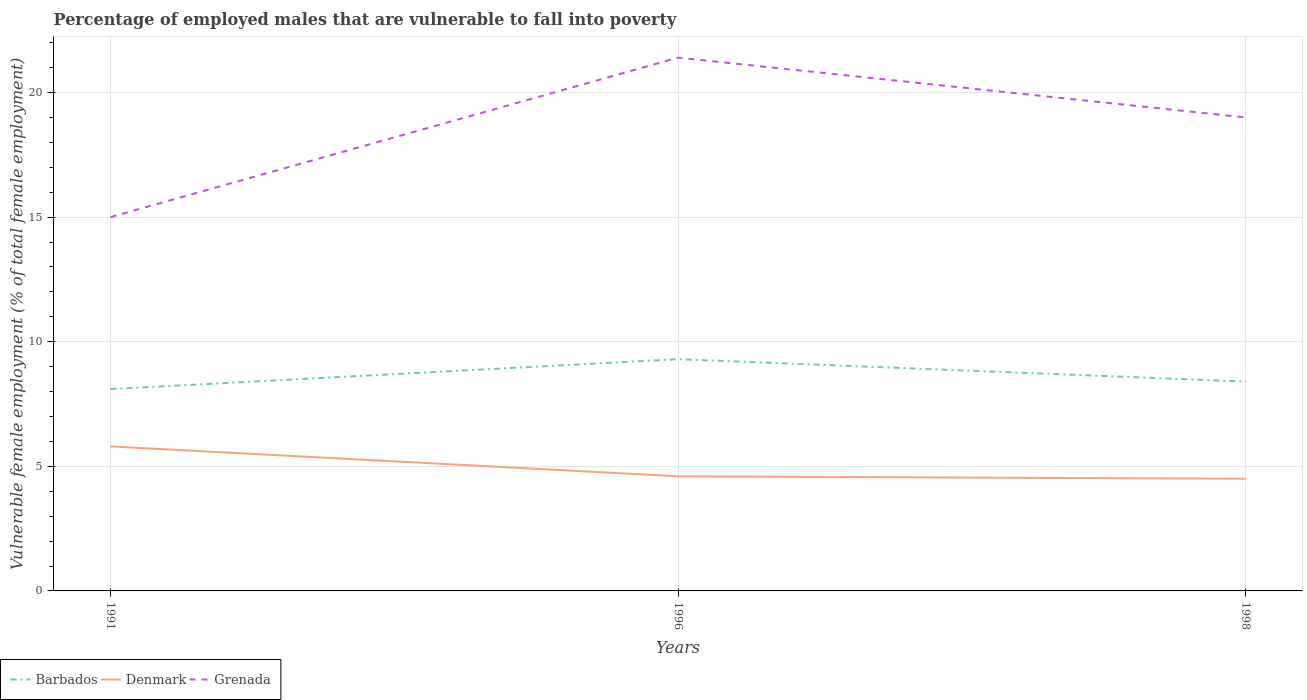How many different coloured lines are there?
Provide a succinct answer. 3. Across all years, what is the maximum percentage of employed males who are vulnerable to fall into poverty in Barbados?
Offer a very short reply. 8.1. In which year was the percentage of employed males who are vulnerable to fall into poverty in Barbados maximum?
Your response must be concise. 1991. What is the total percentage of employed males who are vulnerable to fall into poverty in Barbados in the graph?
Your answer should be very brief. 0.9. What is the difference between the highest and the second highest percentage of employed males who are vulnerable to fall into poverty in Denmark?
Keep it short and to the point. 1.3. How many lines are there?
Offer a terse response. 3. Are the values on the major ticks of Y-axis written in scientific E-notation?
Your response must be concise. No. Does the graph contain grids?
Your response must be concise. Yes. How are the legend labels stacked?
Ensure brevity in your answer.  Horizontal. What is the title of the graph?
Give a very brief answer. Percentage of employed males that are vulnerable to fall into poverty. Does "Dominican Republic" appear as one of the legend labels in the graph?
Provide a short and direct response. No. What is the label or title of the Y-axis?
Give a very brief answer. Vulnerable female employment (% of total female employment). What is the Vulnerable female employment (% of total female employment) of Barbados in 1991?
Your answer should be very brief. 8.1. What is the Vulnerable female employment (% of total female employment) in Denmark in 1991?
Make the answer very short. 5.8. What is the Vulnerable female employment (% of total female employment) of Grenada in 1991?
Ensure brevity in your answer.  15. What is the Vulnerable female employment (% of total female employment) of Barbados in 1996?
Your answer should be compact. 9.3. What is the Vulnerable female employment (% of total female employment) in Denmark in 1996?
Provide a short and direct response. 4.6. What is the Vulnerable female employment (% of total female employment) in Grenada in 1996?
Offer a terse response. 21.4. What is the Vulnerable female employment (% of total female employment) of Barbados in 1998?
Your answer should be compact. 8.4. Across all years, what is the maximum Vulnerable female employment (% of total female employment) of Barbados?
Make the answer very short. 9.3. Across all years, what is the maximum Vulnerable female employment (% of total female employment) in Denmark?
Provide a succinct answer. 5.8. Across all years, what is the maximum Vulnerable female employment (% of total female employment) of Grenada?
Offer a very short reply. 21.4. Across all years, what is the minimum Vulnerable female employment (% of total female employment) in Barbados?
Keep it short and to the point. 8.1. Across all years, what is the minimum Vulnerable female employment (% of total female employment) of Denmark?
Offer a terse response. 4.5. What is the total Vulnerable female employment (% of total female employment) of Barbados in the graph?
Ensure brevity in your answer.  25.8. What is the total Vulnerable female employment (% of total female employment) in Denmark in the graph?
Your answer should be compact. 14.9. What is the total Vulnerable female employment (% of total female employment) of Grenada in the graph?
Your answer should be very brief. 55.4. What is the difference between the Vulnerable female employment (% of total female employment) in Barbados in 1991 and that in 1996?
Keep it short and to the point. -1.2. What is the difference between the Vulnerable female employment (% of total female employment) of Denmark in 1991 and that in 1996?
Your answer should be very brief. 1.2. What is the difference between the Vulnerable female employment (% of total female employment) of Barbados in 1991 and that in 1998?
Make the answer very short. -0.3. What is the difference between the Vulnerable female employment (% of total female employment) in Grenada in 1991 and that in 1998?
Offer a terse response. -4. What is the difference between the Vulnerable female employment (% of total female employment) of Denmark in 1996 and that in 1998?
Provide a short and direct response. 0.1. What is the difference between the Vulnerable female employment (% of total female employment) in Grenada in 1996 and that in 1998?
Offer a very short reply. 2.4. What is the difference between the Vulnerable female employment (% of total female employment) in Denmark in 1991 and the Vulnerable female employment (% of total female employment) in Grenada in 1996?
Make the answer very short. -15.6. What is the difference between the Vulnerable female employment (% of total female employment) of Barbados in 1996 and the Vulnerable female employment (% of total female employment) of Denmark in 1998?
Your answer should be compact. 4.8. What is the difference between the Vulnerable female employment (% of total female employment) in Denmark in 1996 and the Vulnerable female employment (% of total female employment) in Grenada in 1998?
Offer a very short reply. -14.4. What is the average Vulnerable female employment (% of total female employment) of Barbados per year?
Provide a short and direct response. 8.6. What is the average Vulnerable female employment (% of total female employment) of Denmark per year?
Keep it short and to the point. 4.97. What is the average Vulnerable female employment (% of total female employment) of Grenada per year?
Offer a terse response. 18.47. In the year 1991, what is the difference between the Vulnerable female employment (% of total female employment) in Barbados and Vulnerable female employment (% of total female employment) in Denmark?
Your response must be concise. 2.3. In the year 1996, what is the difference between the Vulnerable female employment (% of total female employment) in Barbados and Vulnerable female employment (% of total female employment) in Denmark?
Your response must be concise. 4.7. In the year 1996, what is the difference between the Vulnerable female employment (% of total female employment) of Barbados and Vulnerable female employment (% of total female employment) of Grenada?
Provide a short and direct response. -12.1. In the year 1996, what is the difference between the Vulnerable female employment (% of total female employment) in Denmark and Vulnerable female employment (% of total female employment) in Grenada?
Keep it short and to the point. -16.8. In the year 1998, what is the difference between the Vulnerable female employment (% of total female employment) of Barbados and Vulnerable female employment (% of total female employment) of Denmark?
Provide a short and direct response. 3.9. In the year 1998, what is the difference between the Vulnerable female employment (% of total female employment) in Barbados and Vulnerable female employment (% of total female employment) in Grenada?
Keep it short and to the point. -10.6. What is the ratio of the Vulnerable female employment (% of total female employment) of Barbados in 1991 to that in 1996?
Ensure brevity in your answer.  0.87. What is the ratio of the Vulnerable female employment (% of total female employment) of Denmark in 1991 to that in 1996?
Your response must be concise. 1.26. What is the ratio of the Vulnerable female employment (% of total female employment) of Grenada in 1991 to that in 1996?
Ensure brevity in your answer.  0.7. What is the ratio of the Vulnerable female employment (% of total female employment) of Denmark in 1991 to that in 1998?
Provide a succinct answer. 1.29. What is the ratio of the Vulnerable female employment (% of total female employment) of Grenada in 1991 to that in 1998?
Your answer should be very brief. 0.79. What is the ratio of the Vulnerable female employment (% of total female employment) of Barbados in 1996 to that in 1998?
Your answer should be compact. 1.11. What is the ratio of the Vulnerable female employment (% of total female employment) in Denmark in 1996 to that in 1998?
Make the answer very short. 1.02. What is the ratio of the Vulnerable female employment (% of total female employment) of Grenada in 1996 to that in 1998?
Ensure brevity in your answer.  1.13. What is the difference between the highest and the second highest Vulnerable female employment (% of total female employment) in Grenada?
Keep it short and to the point. 2.4. What is the difference between the highest and the lowest Vulnerable female employment (% of total female employment) in Denmark?
Provide a short and direct response. 1.3. 